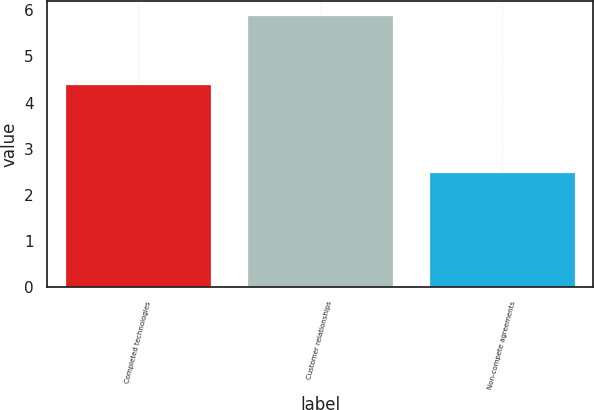Convert chart to OTSL. <chart><loc_0><loc_0><loc_500><loc_500><bar_chart><fcel>Completed technologies<fcel>Customer relationships<fcel>Non-compete agreements<nl><fcel>4.4<fcel>5.9<fcel>2.5<nl></chart> 